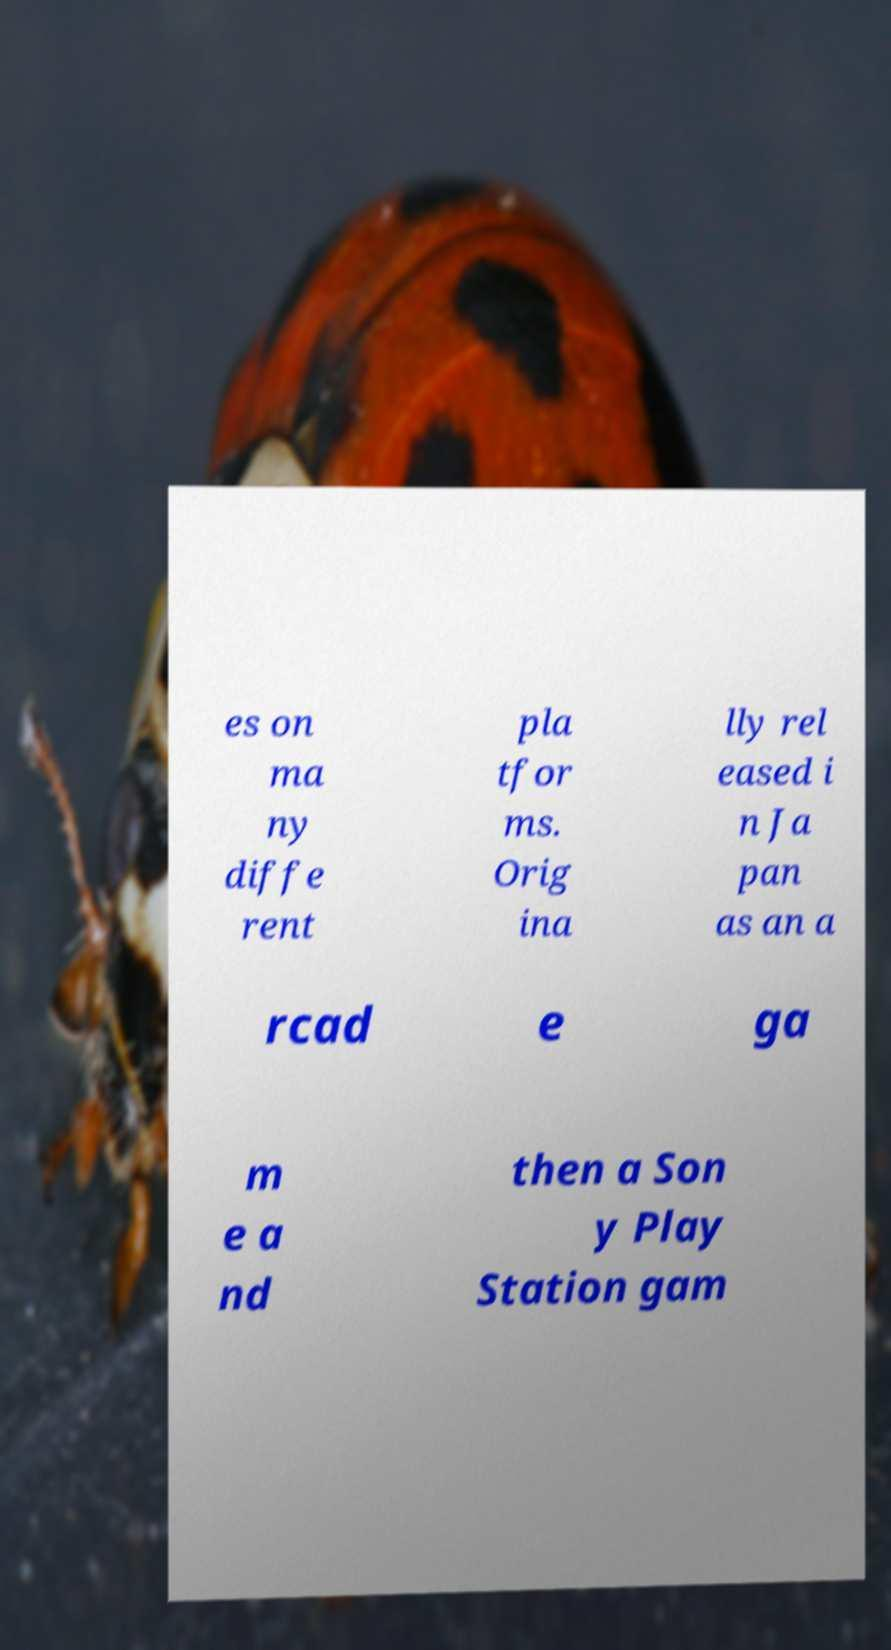Could you assist in decoding the text presented in this image and type it out clearly? es on ma ny diffe rent pla tfor ms. Orig ina lly rel eased i n Ja pan as an a rcad e ga m e a nd then a Son y Play Station gam 